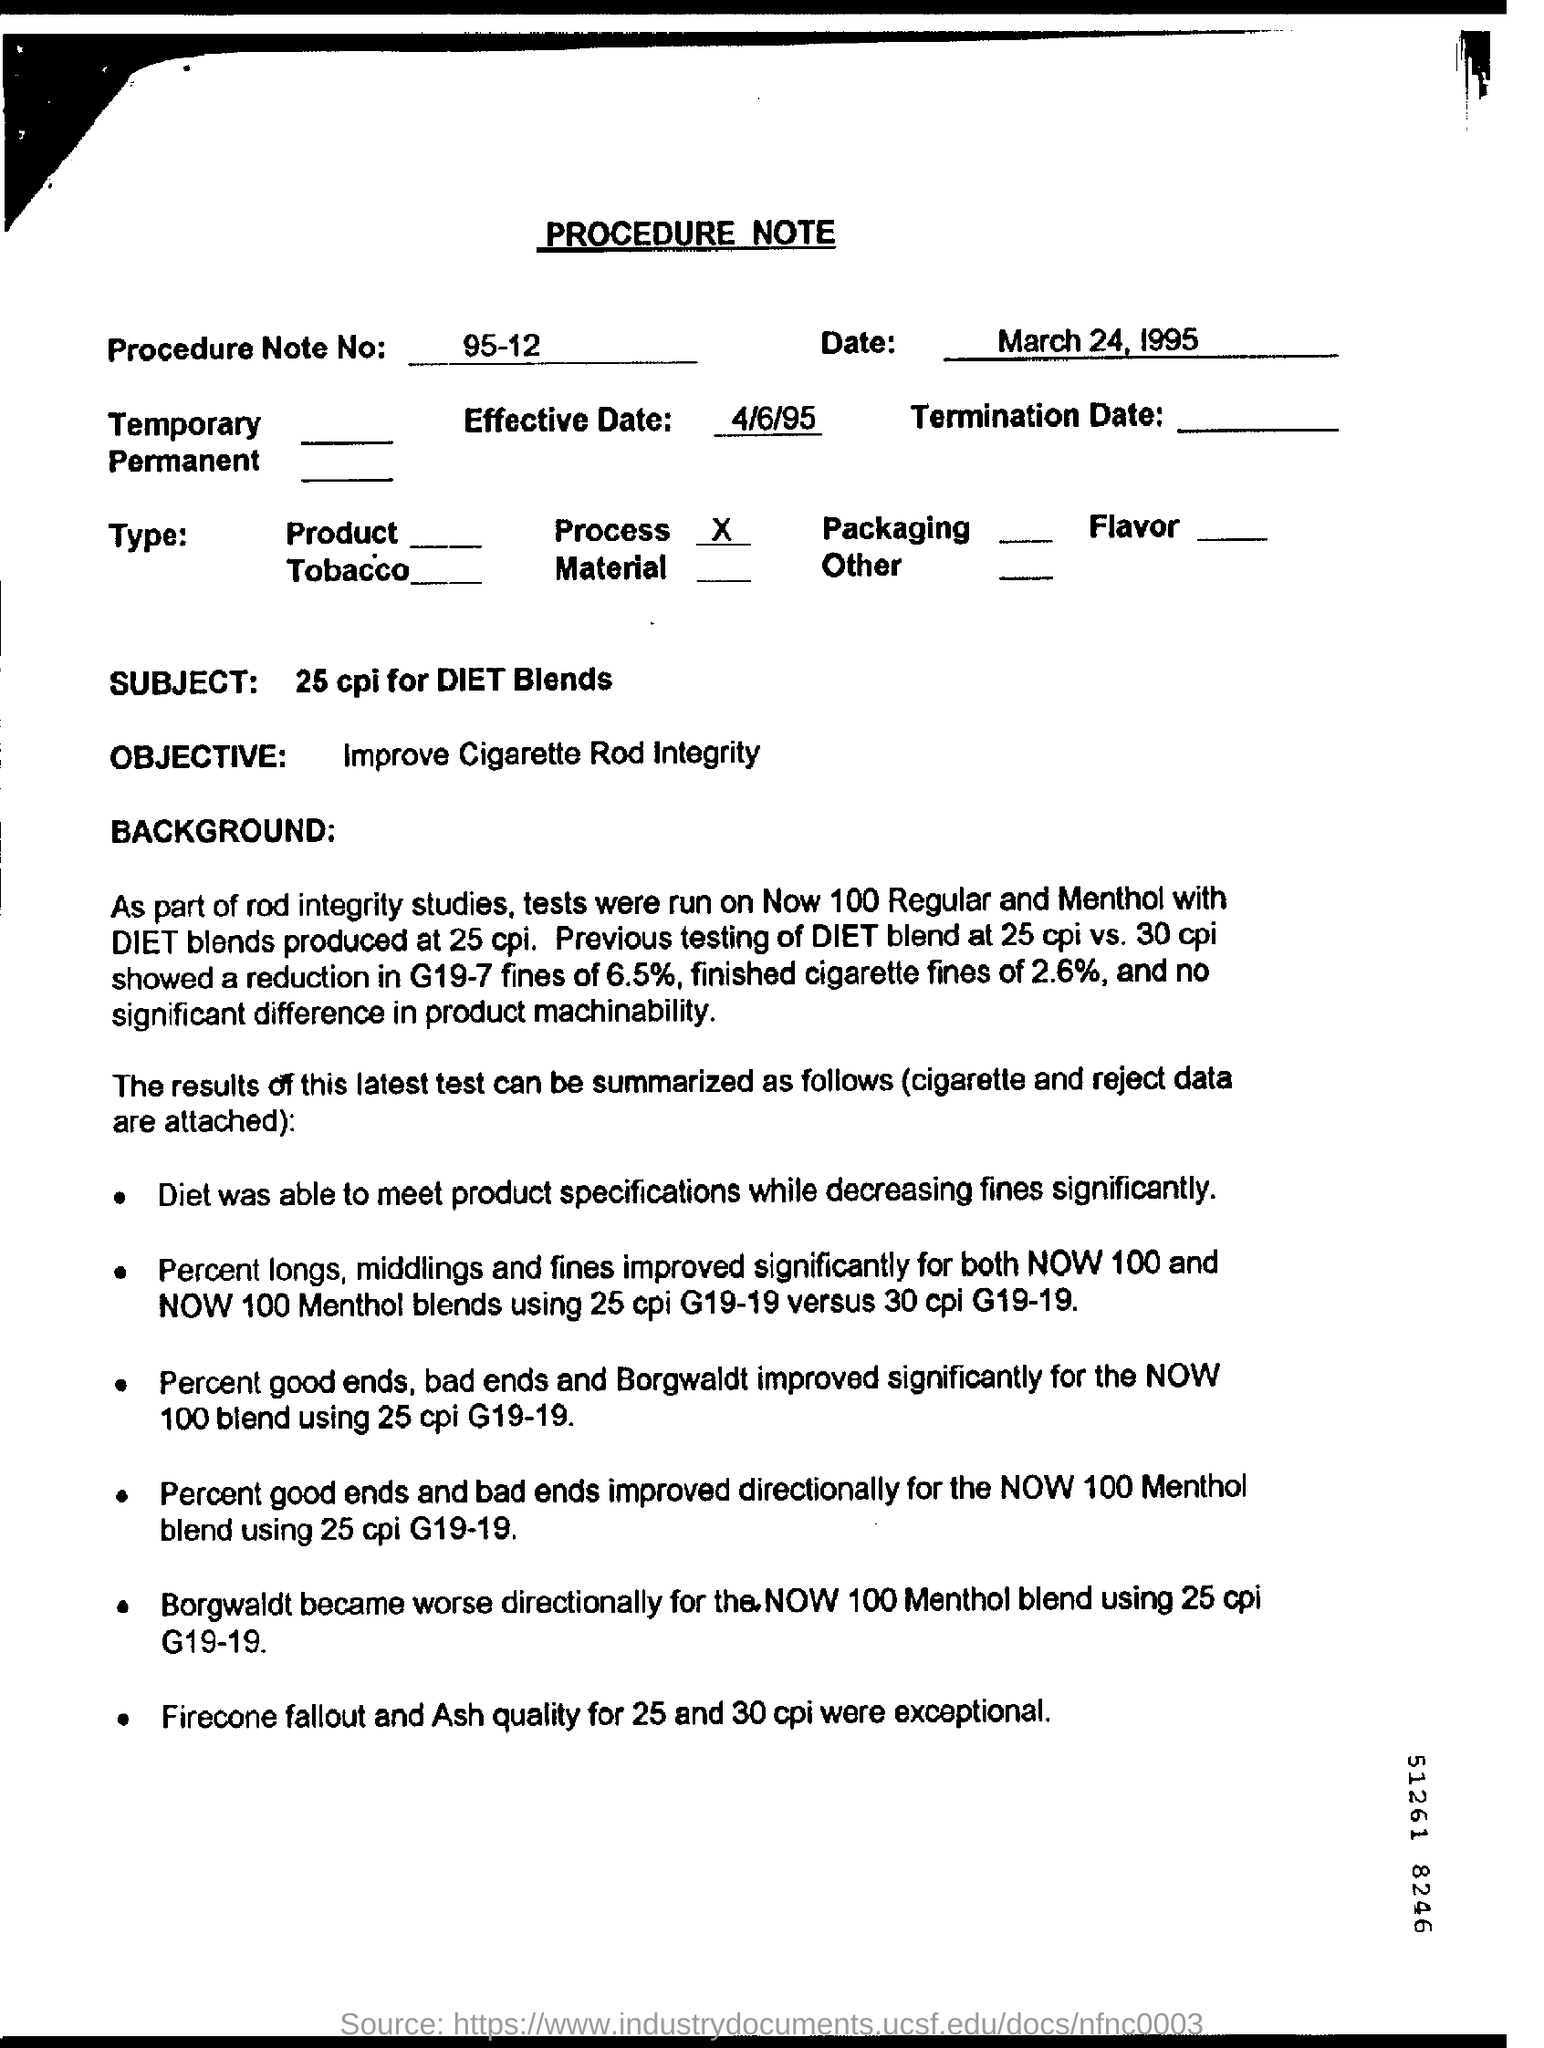Indicate a few pertinent items in this graphic. The subject of the procedure note is the 25 cpi for DIET blends. The Procedure Note No. is 95-12. The date mentioned in the form is April 6, 1995. 